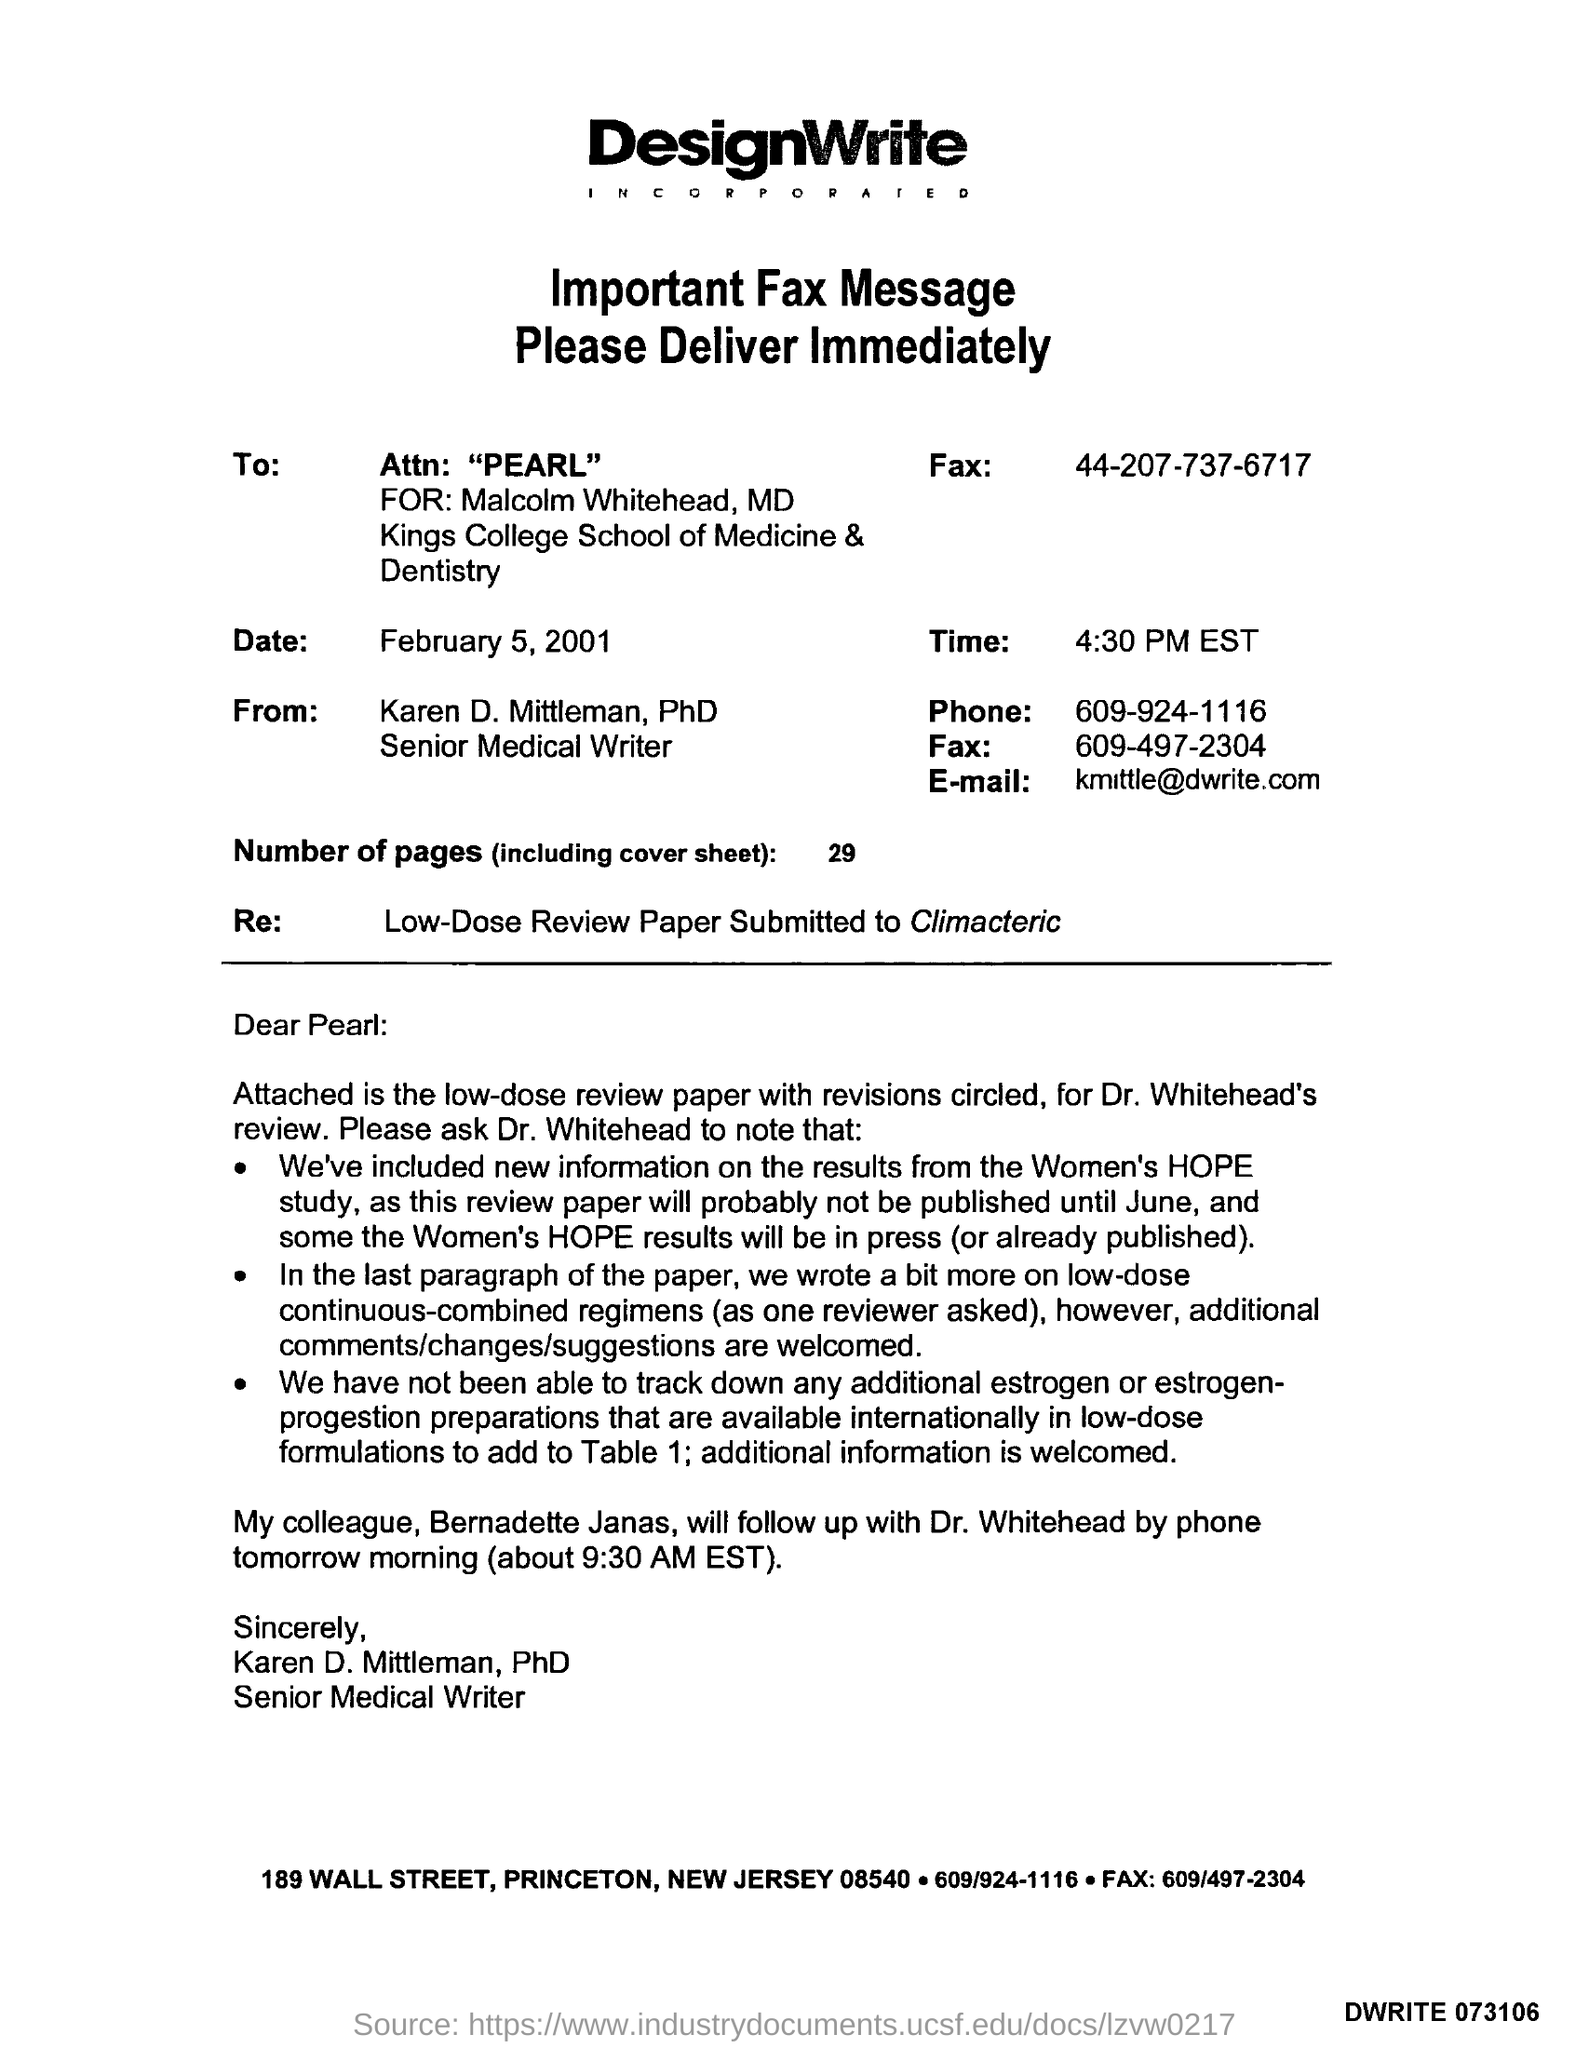What is "Attn" mentioned?
Offer a terse response. PEARL. 